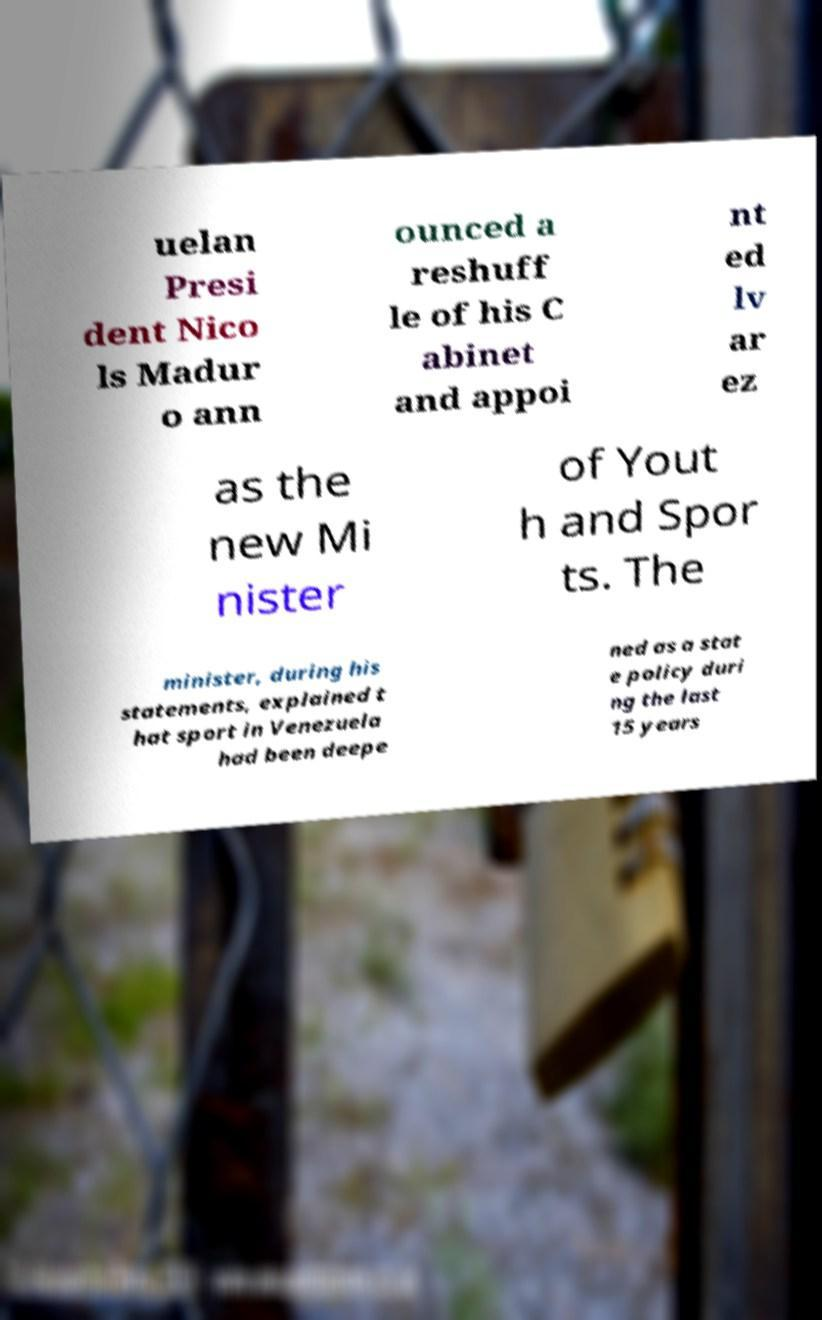Could you assist in decoding the text presented in this image and type it out clearly? uelan Presi dent Nico ls Madur o ann ounced a reshuff le of his C abinet and appoi nt ed lv ar ez as the new Mi nister of Yout h and Spor ts. The minister, during his statements, explained t hat sport in Venezuela had been deepe ned as a stat e policy duri ng the last 15 years 